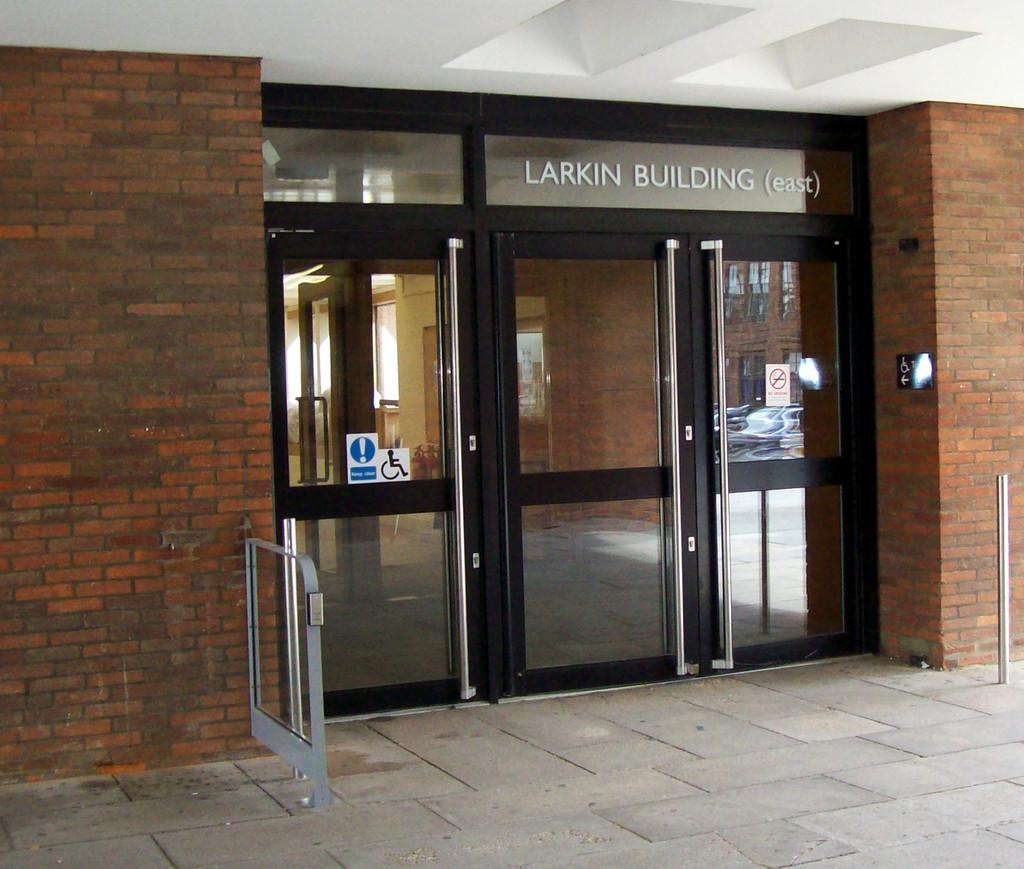What type of door is visible in the image? There is a glass door in the image. What is located on the left side of the image? There is a brick wall on the left side of the image. What is located on the right side of the image? There is a brick wall on the right side of the image. What can be seen on the glass door? There are labels pasted on the glass door. How many cubs are playing on the brick wall in the image? There are no cubs present in the image; it features a glass door with labels and brick walls on both sides. Can you tell me how many girls are walking through the glass door in the image? There are no girls walking through the glass door in the image. 